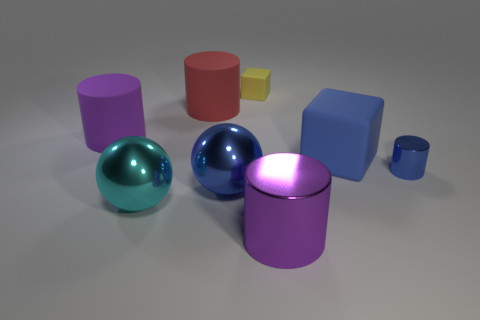Subtract 1 cylinders. How many cylinders are left? 3 Subtract all green cylinders. Subtract all green cubes. How many cylinders are left? 4 Add 1 large yellow rubber objects. How many objects exist? 9 Subtract all balls. How many objects are left? 6 Subtract all large cyan objects. Subtract all blue spheres. How many objects are left? 6 Add 4 red matte objects. How many red matte objects are left? 5 Add 7 red matte objects. How many red matte objects exist? 8 Subtract 0 red cubes. How many objects are left? 8 